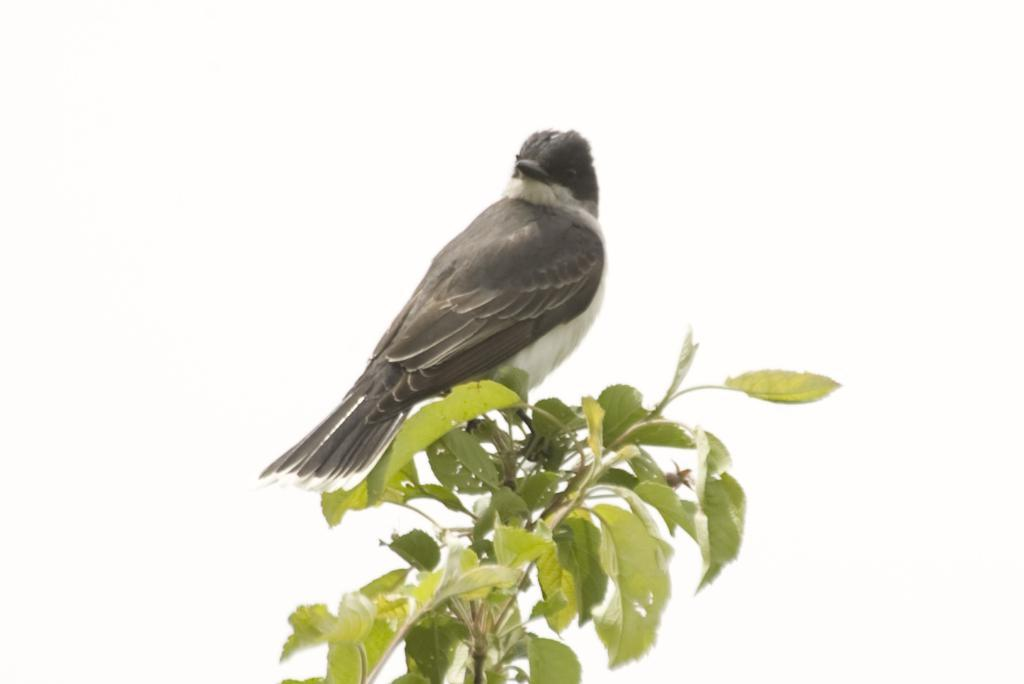What type of animal is in the image? There is a bird in the image. Where is the bird located? The bird is on a stem. What color is the background of the image? The background of the image is white. What is the bird's income in the image? There is no information about the bird's income in the image, as birds do not have income. 